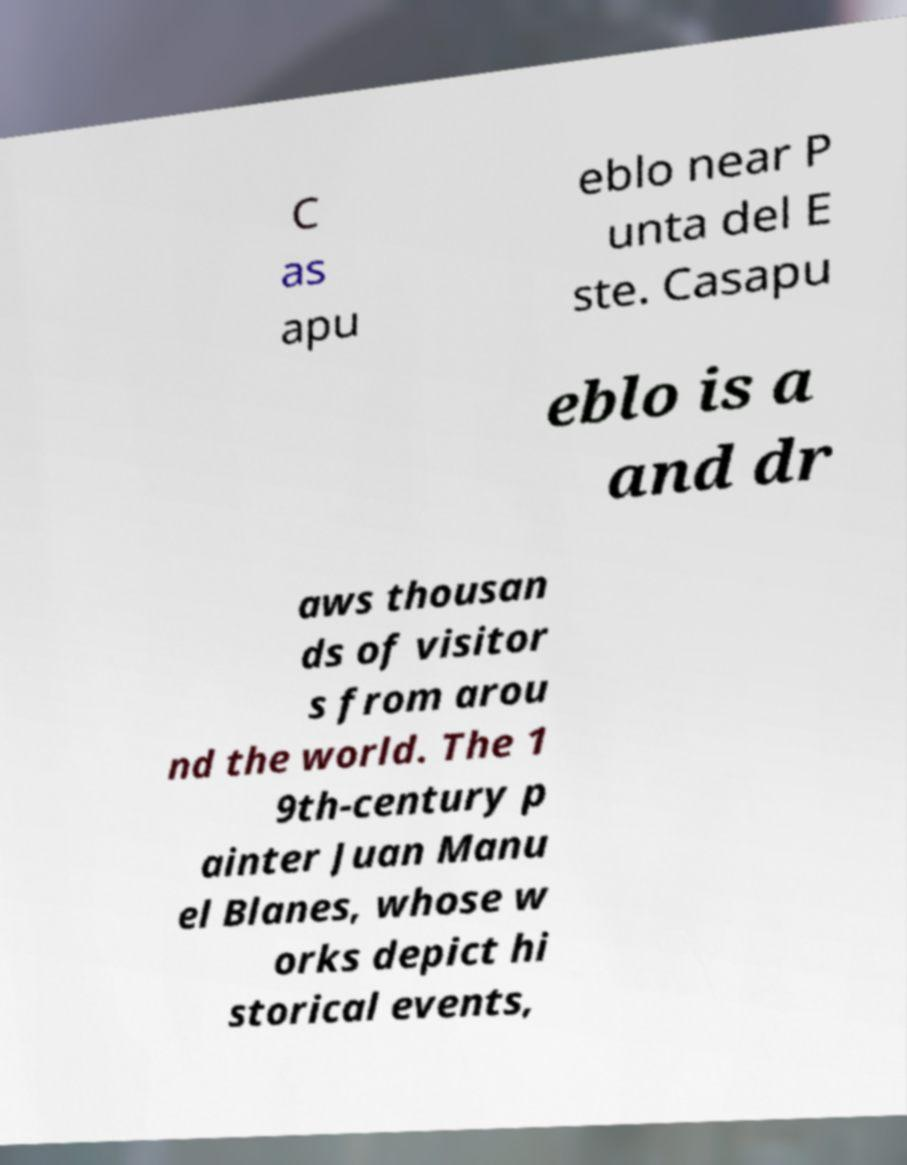Can you accurately transcribe the text from the provided image for me? C as apu eblo near P unta del E ste. Casapu eblo is a and dr aws thousan ds of visitor s from arou nd the world. The 1 9th-century p ainter Juan Manu el Blanes, whose w orks depict hi storical events, 